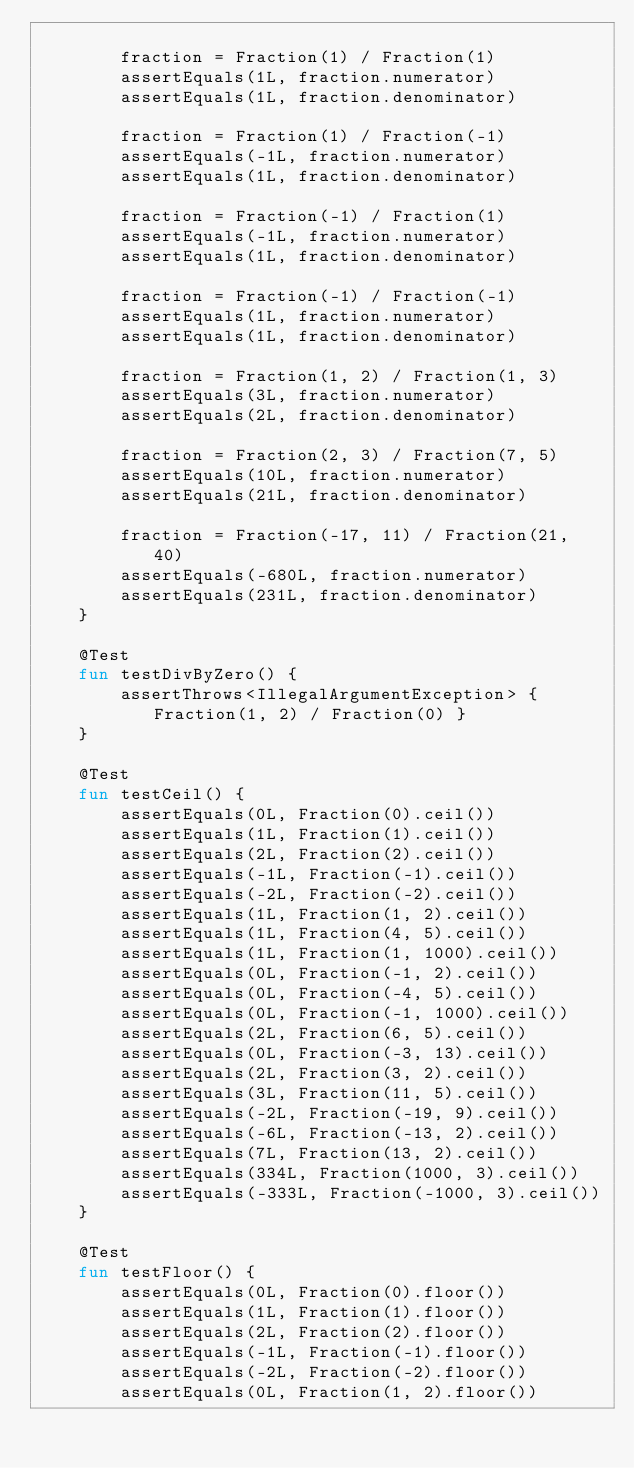<code> <loc_0><loc_0><loc_500><loc_500><_Kotlin_>
        fraction = Fraction(1) / Fraction(1)
        assertEquals(1L, fraction.numerator)
        assertEquals(1L, fraction.denominator)

        fraction = Fraction(1) / Fraction(-1)
        assertEquals(-1L, fraction.numerator)
        assertEquals(1L, fraction.denominator)

        fraction = Fraction(-1) / Fraction(1)
        assertEquals(-1L, fraction.numerator)
        assertEquals(1L, fraction.denominator)

        fraction = Fraction(-1) / Fraction(-1)
        assertEquals(1L, fraction.numerator)
        assertEquals(1L, fraction.denominator)

        fraction = Fraction(1, 2) / Fraction(1, 3)
        assertEquals(3L, fraction.numerator)
        assertEquals(2L, fraction.denominator)

        fraction = Fraction(2, 3) / Fraction(7, 5)
        assertEquals(10L, fraction.numerator)
        assertEquals(21L, fraction.denominator)

        fraction = Fraction(-17, 11) / Fraction(21, 40)
        assertEquals(-680L, fraction.numerator)
        assertEquals(231L, fraction.denominator)
    }

    @Test
    fun testDivByZero() {
        assertThrows<IllegalArgumentException> { Fraction(1, 2) / Fraction(0) }
    }

    @Test
    fun testCeil() {
        assertEquals(0L, Fraction(0).ceil())
        assertEquals(1L, Fraction(1).ceil())
        assertEquals(2L, Fraction(2).ceil())
        assertEquals(-1L, Fraction(-1).ceil())
        assertEquals(-2L, Fraction(-2).ceil())
        assertEquals(1L, Fraction(1, 2).ceil())
        assertEquals(1L, Fraction(4, 5).ceil())
        assertEquals(1L, Fraction(1, 1000).ceil())
        assertEquals(0L, Fraction(-1, 2).ceil())
        assertEquals(0L, Fraction(-4, 5).ceil())
        assertEquals(0L, Fraction(-1, 1000).ceil())
        assertEquals(2L, Fraction(6, 5).ceil())
        assertEquals(0L, Fraction(-3, 13).ceil())
        assertEquals(2L, Fraction(3, 2).ceil())
        assertEquals(3L, Fraction(11, 5).ceil())
        assertEquals(-2L, Fraction(-19, 9).ceil())
        assertEquals(-6L, Fraction(-13, 2).ceil())
        assertEquals(7L, Fraction(13, 2).ceil())
        assertEquals(334L, Fraction(1000, 3).ceil())
        assertEquals(-333L, Fraction(-1000, 3).ceil())
    }

    @Test
    fun testFloor() {
        assertEquals(0L, Fraction(0).floor())
        assertEquals(1L, Fraction(1).floor())
        assertEquals(2L, Fraction(2).floor())
        assertEquals(-1L, Fraction(-1).floor())
        assertEquals(-2L, Fraction(-2).floor())
        assertEquals(0L, Fraction(1, 2).floor())</code> 